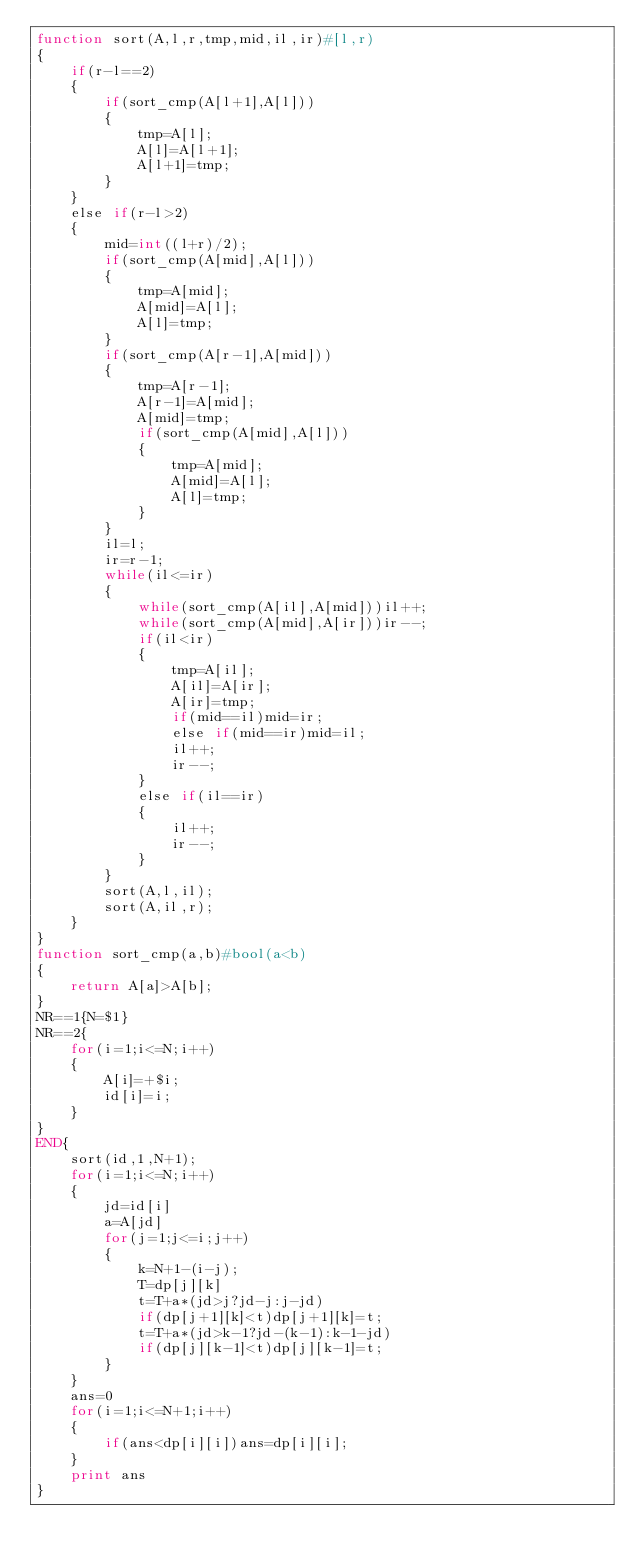Convert code to text. <code><loc_0><loc_0><loc_500><loc_500><_Awk_>function sort(A,l,r,tmp,mid,il,ir)#[l,r)
{
	if(r-l==2)
	{
		if(sort_cmp(A[l+1],A[l]))
		{
			tmp=A[l];
			A[l]=A[l+1];
			A[l+1]=tmp;
		}
	}
	else if(r-l>2)
	{
		mid=int((l+r)/2);
		if(sort_cmp(A[mid],A[l]))
		{
			tmp=A[mid];
			A[mid]=A[l];
			A[l]=tmp;
		}
		if(sort_cmp(A[r-1],A[mid]))
		{
			tmp=A[r-1];
			A[r-1]=A[mid];
			A[mid]=tmp;
			if(sort_cmp(A[mid],A[l]))
			{
				tmp=A[mid];
				A[mid]=A[l];
				A[l]=tmp;
			}
		}
		il=l;
		ir=r-1;
		while(il<=ir)
		{
			while(sort_cmp(A[il],A[mid]))il++;
			while(sort_cmp(A[mid],A[ir]))ir--;
			if(il<ir)
			{
				tmp=A[il];
				A[il]=A[ir];
				A[ir]=tmp;
				if(mid==il)mid=ir;
				else if(mid==ir)mid=il;
				il++;
				ir--;
			}
			else if(il==ir)
			{
				il++;
				ir--;
			}
		}
		sort(A,l,il);
		sort(A,il,r);
	}
}
function sort_cmp(a,b)#bool(a<b)
{
	return A[a]>A[b];
}
NR==1{N=$1}
NR==2{
	for(i=1;i<=N;i++)
	{
		A[i]=+$i;
		id[i]=i;
	}
}
END{
	sort(id,1,N+1);
	for(i=1;i<=N;i++)
	{
		jd=id[i]
		a=A[jd]
		for(j=1;j<=i;j++)
		{
			k=N+1-(i-j);
			T=dp[j][k]
			t=T+a*(jd>j?jd-j:j-jd)
			if(dp[j+1][k]<t)dp[j+1][k]=t;
			t=T+a*(jd>k-1?jd-(k-1):k-1-jd)
			if(dp[j][k-1]<t)dp[j][k-1]=t;
		}
	}
	ans=0
	for(i=1;i<=N+1;i++)
	{
		if(ans<dp[i][i])ans=dp[i][i];
	}
	print ans
}
</code> 